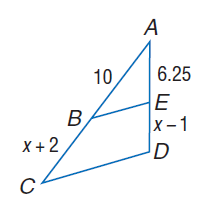Question: Each pair of polygons is similar. Find B C.
Choices:
A. 6.25
B. 8
C. 10
D. 12
Answer with the letter. Answer: B Question: Each pair of polygons is similar. Find E D.
Choices:
A. 5
B. 6.25
C. 10
D. 95
Answer with the letter. Answer: A 